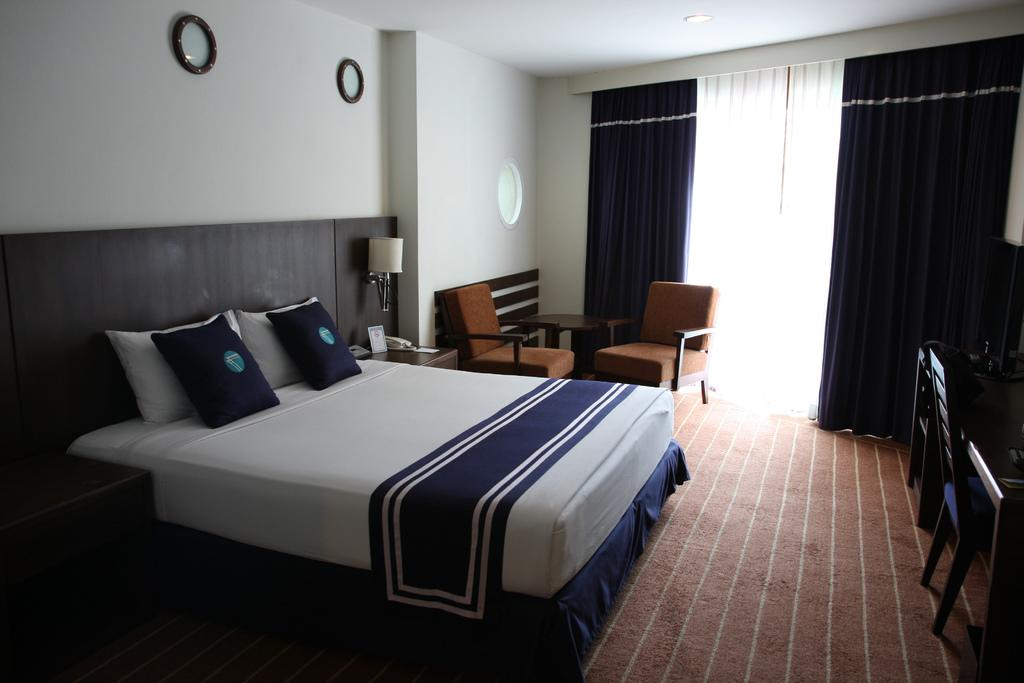What type of furniture is present in the image? There is a bed, a table, and a chair in the image. What can be found on the bed? The bed has a bed sheet and pillows. Can you describe the lighting in the image? There is a lamp in the image. What communication device is visible in the image? There is a telephone in the image. What type of decoration is present in the image? There is a frame in the image. What can be seen on the table? There is paper on the table. What type of window treatment is present in the image? There are curtains in the image. What is the primary architectural feature in the image? There is a wall in the image. Are there any unspecified objects in the image? Yes, there are some unspecified objects in the image. What type of plantation can be seen in the image? There is no plantation present in the image. What country is depicted in the image? The image does not depict a specific country. Can you see the moon in the image? The moon is not visible in the image. 